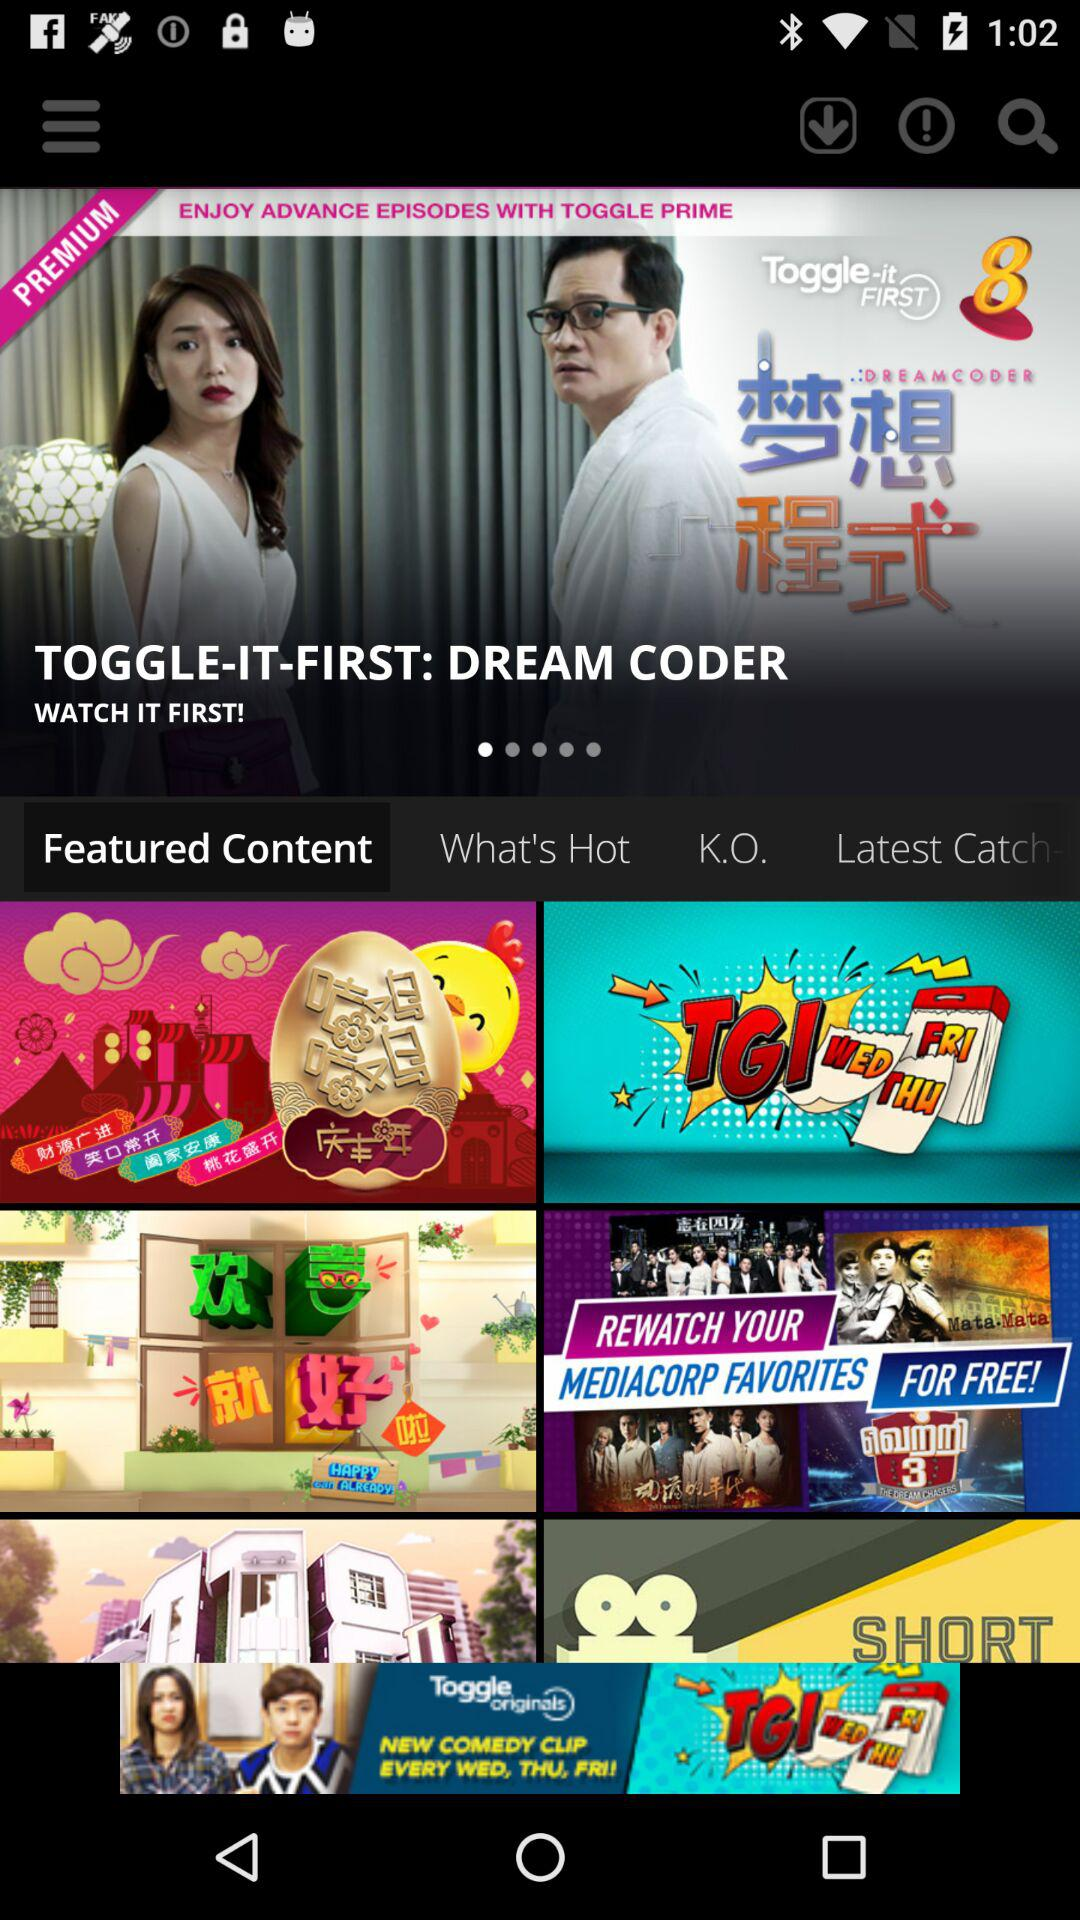What is the title of the drama that is available in the premium option? The title is "DREAM CODER". 